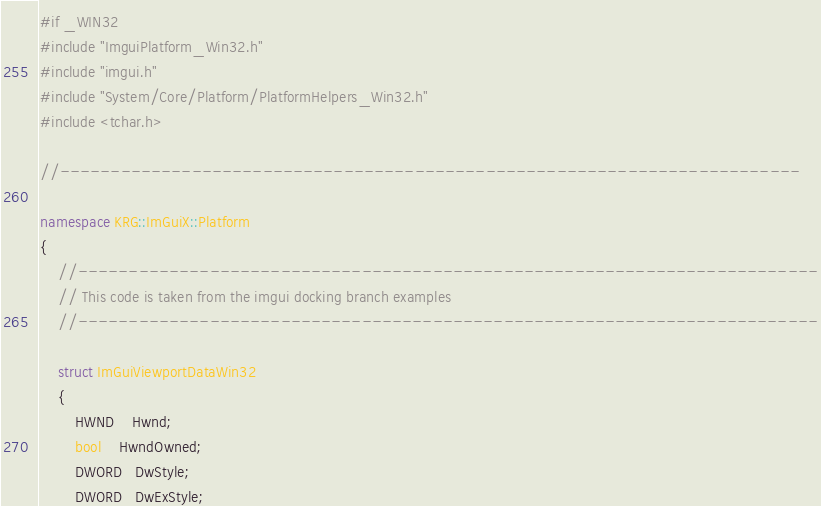<code> <loc_0><loc_0><loc_500><loc_500><_C++_>#if _WIN32
#include "ImguiPlatform_Win32.h"
#include "imgui.h"
#include "System/Core/Platform/PlatformHelpers_Win32.h"
#include <tchar.h>

//-------------------------------------------------------------------------

namespace KRG::ImGuiX::Platform
{
    //-------------------------------------------------------------------------
    // This code is taken from the imgui docking branch examples
    //-------------------------------------------------------------------------

    struct ImGuiViewportDataWin32
    {
        HWND    Hwnd;
        bool    HwndOwned;
        DWORD   DwStyle;
        DWORD   DwExStyle;
</code> 